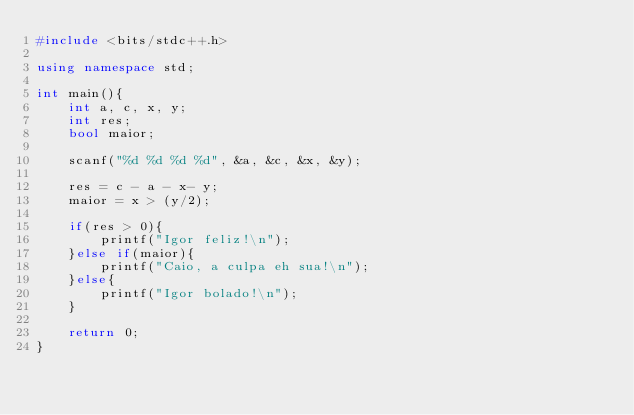<code> <loc_0><loc_0><loc_500><loc_500><_C++_>#include <bits/stdc++.h>

using namespace std;

int main(){
	int a, c, x, y;
	int res;
	bool maior;

	scanf("%d %d %d %d", &a, &c, &x, &y);

	res = c - a - x- y;
	maior = x > (y/2);

	if(res > 0){
		printf("Igor feliz!\n");
	}else if(maior){
		printf("Caio, a culpa eh sua!\n");
	}else{
		printf("Igor bolado!\n");
	}

	return 0;
}</code> 